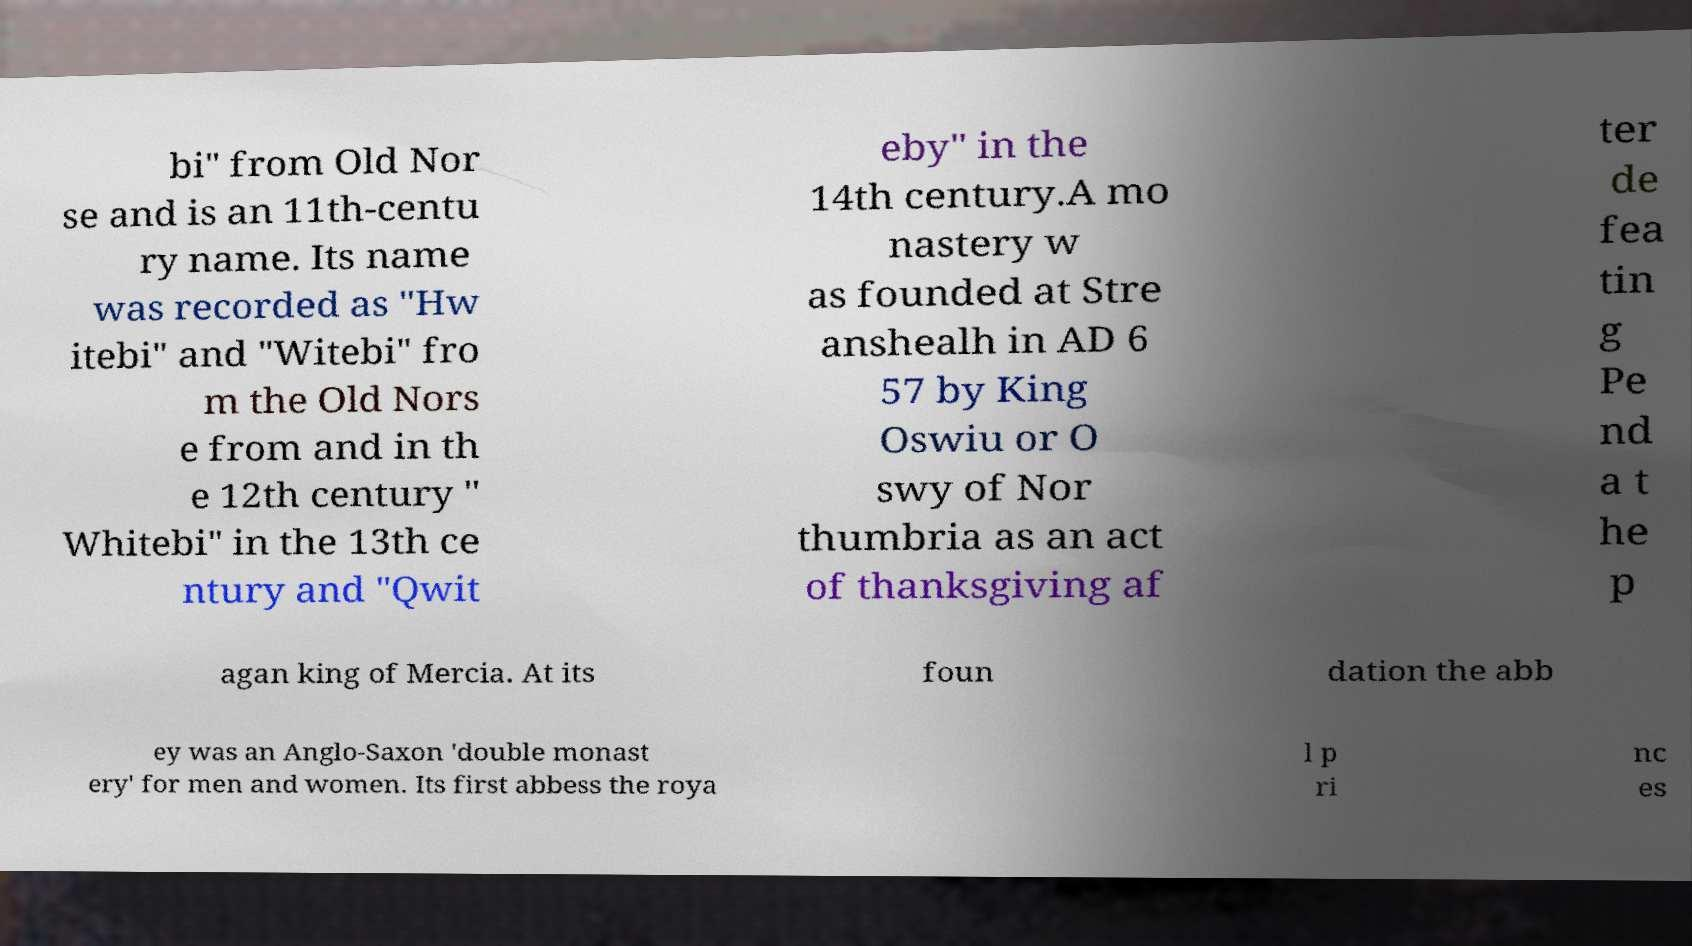Can you read and provide the text displayed in the image?This photo seems to have some interesting text. Can you extract and type it out for me? bi" from Old Nor se and is an 11th-centu ry name. Its name was recorded as "Hw itebi" and "Witebi" fro m the Old Nors e from and in th e 12th century " Whitebi" in the 13th ce ntury and "Qwit eby" in the 14th century.A mo nastery w as founded at Stre anshealh in AD 6 57 by King Oswiu or O swy of Nor thumbria as an act of thanksgiving af ter de fea tin g Pe nd a t he p agan king of Mercia. At its foun dation the abb ey was an Anglo-Saxon 'double monast ery' for men and women. Its first abbess the roya l p ri nc es 